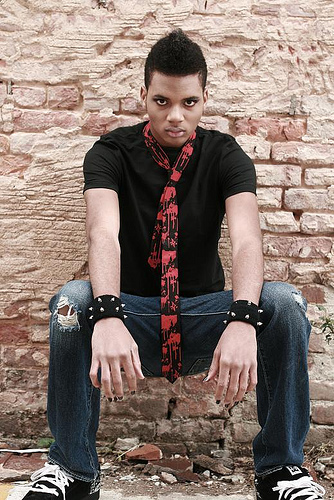What kind of style is the person in the image portraying? The individual in the image is portraying a casual yet edgy style, emphasized by the ripped jeans, black shirt, rebellious-looking accessories like the studded wristbands, and the red-patterned tie worn loosely around his neck. 